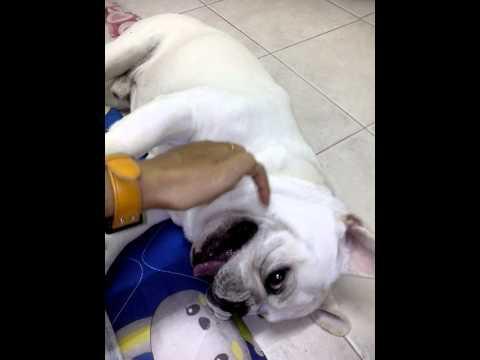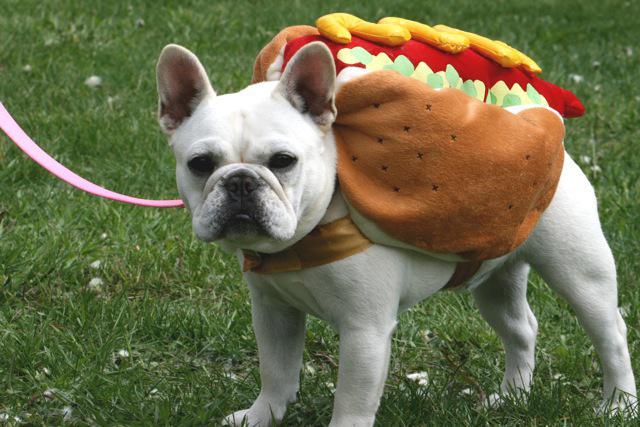The first image is the image on the left, the second image is the image on the right. For the images displayed, is the sentence "A dog's ears are covered by articles of clothing." factually correct? Answer yes or no. No. The first image is the image on the left, the second image is the image on the right. For the images displayed, is the sentence "The dog in the left image is being touched by a human hand." factually correct? Answer yes or no. Yes. 